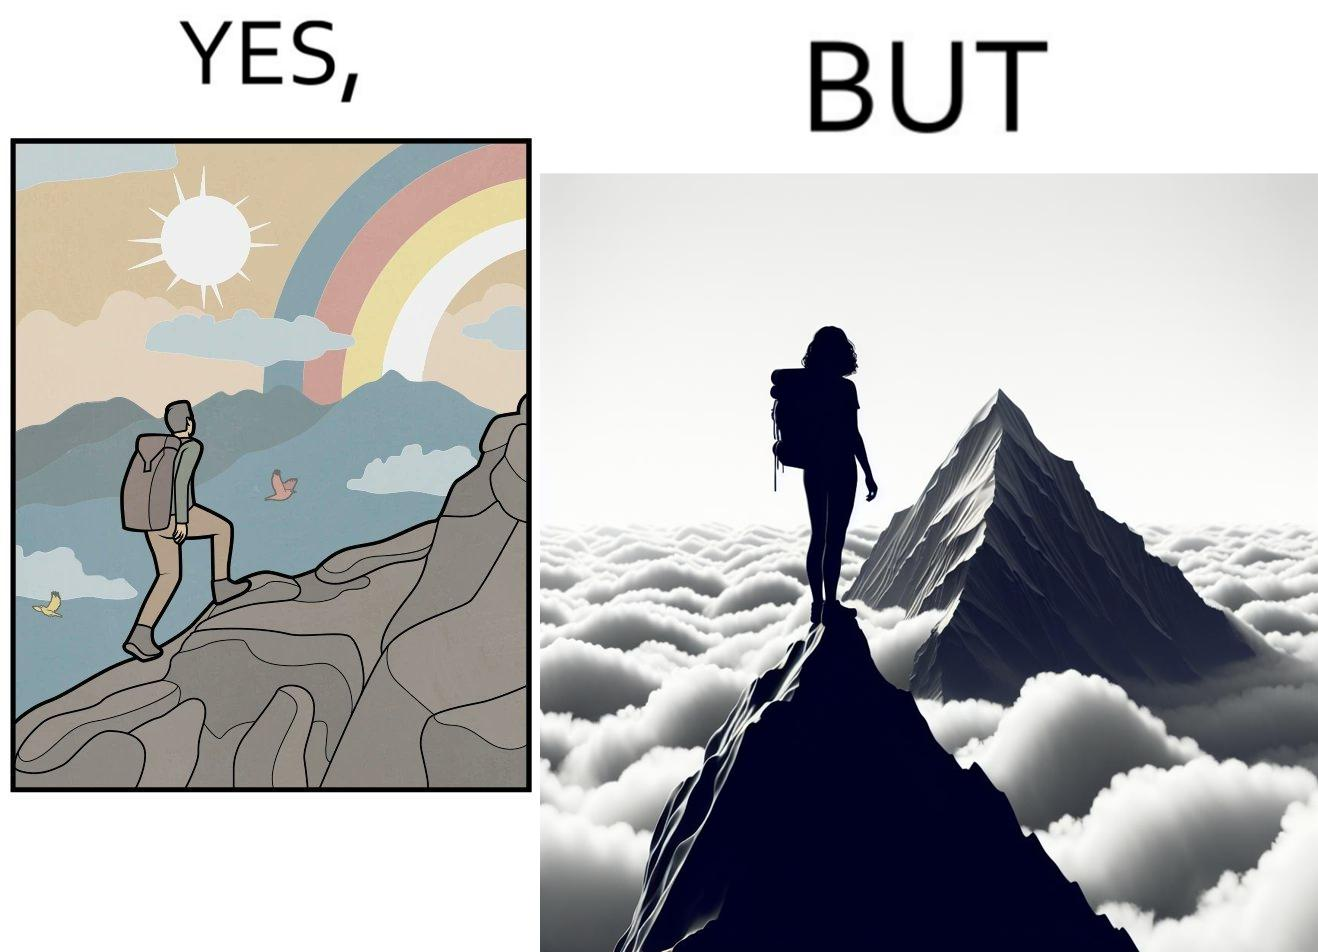Describe the contrast between the left and right parts of this image. In the left part of the image: a mountaineer climbing up the mountain, enjoying the view, birds are flying, rainbow is visible In the right part of the image: a mountaineer is at the peak of the mountain but nothing is visible due to clouds 